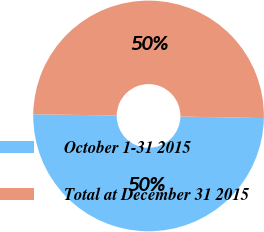Convert chart. <chart><loc_0><loc_0><loc_500><loc_500><pie_chart><fcel>October 1-31 2015<fcel>Total at December 31 2015<nl><fcel>49.93%<fcel>50.07%<nl></chart> 